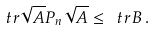Convert formula to latex. <formula><loc_0><loc_0><loc_500><loc_500>\ t r \sqrt { A } P _ { n } \sqrt { A } \leq \ t r { B } \, .</formula> 